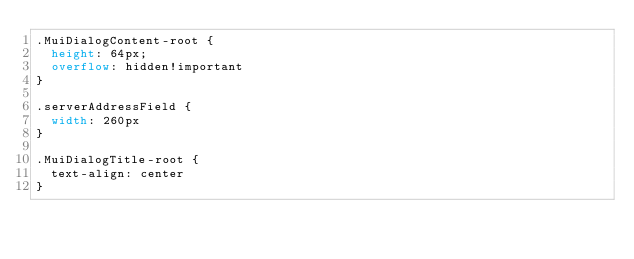<code> <loc_0><loc_0><loc_500><loc_500><_CSS_>.MuiDialogContent-root {
  height: 64px;
  overflow: hidden!important
}

.serverAddressField {
  width: 260px
}

.MuiDialogTitle-root {
  text-align: center
}</code> 